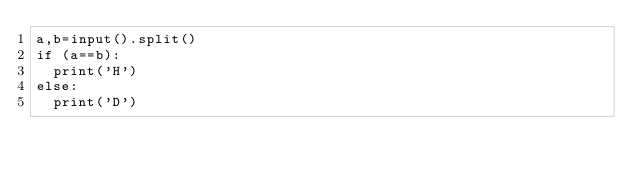<code> <loc_0><loc_0><loc_500><loc_500><_Python_>a,b=input().split()
if (a==b):
  print('H')
else:
  print('D')
</code> 